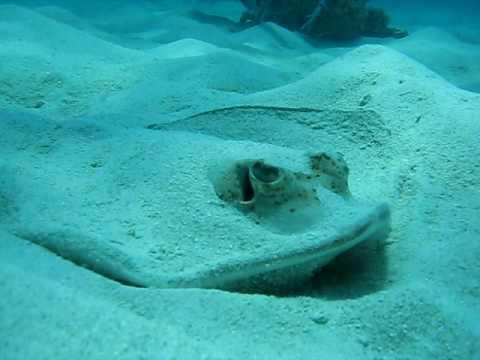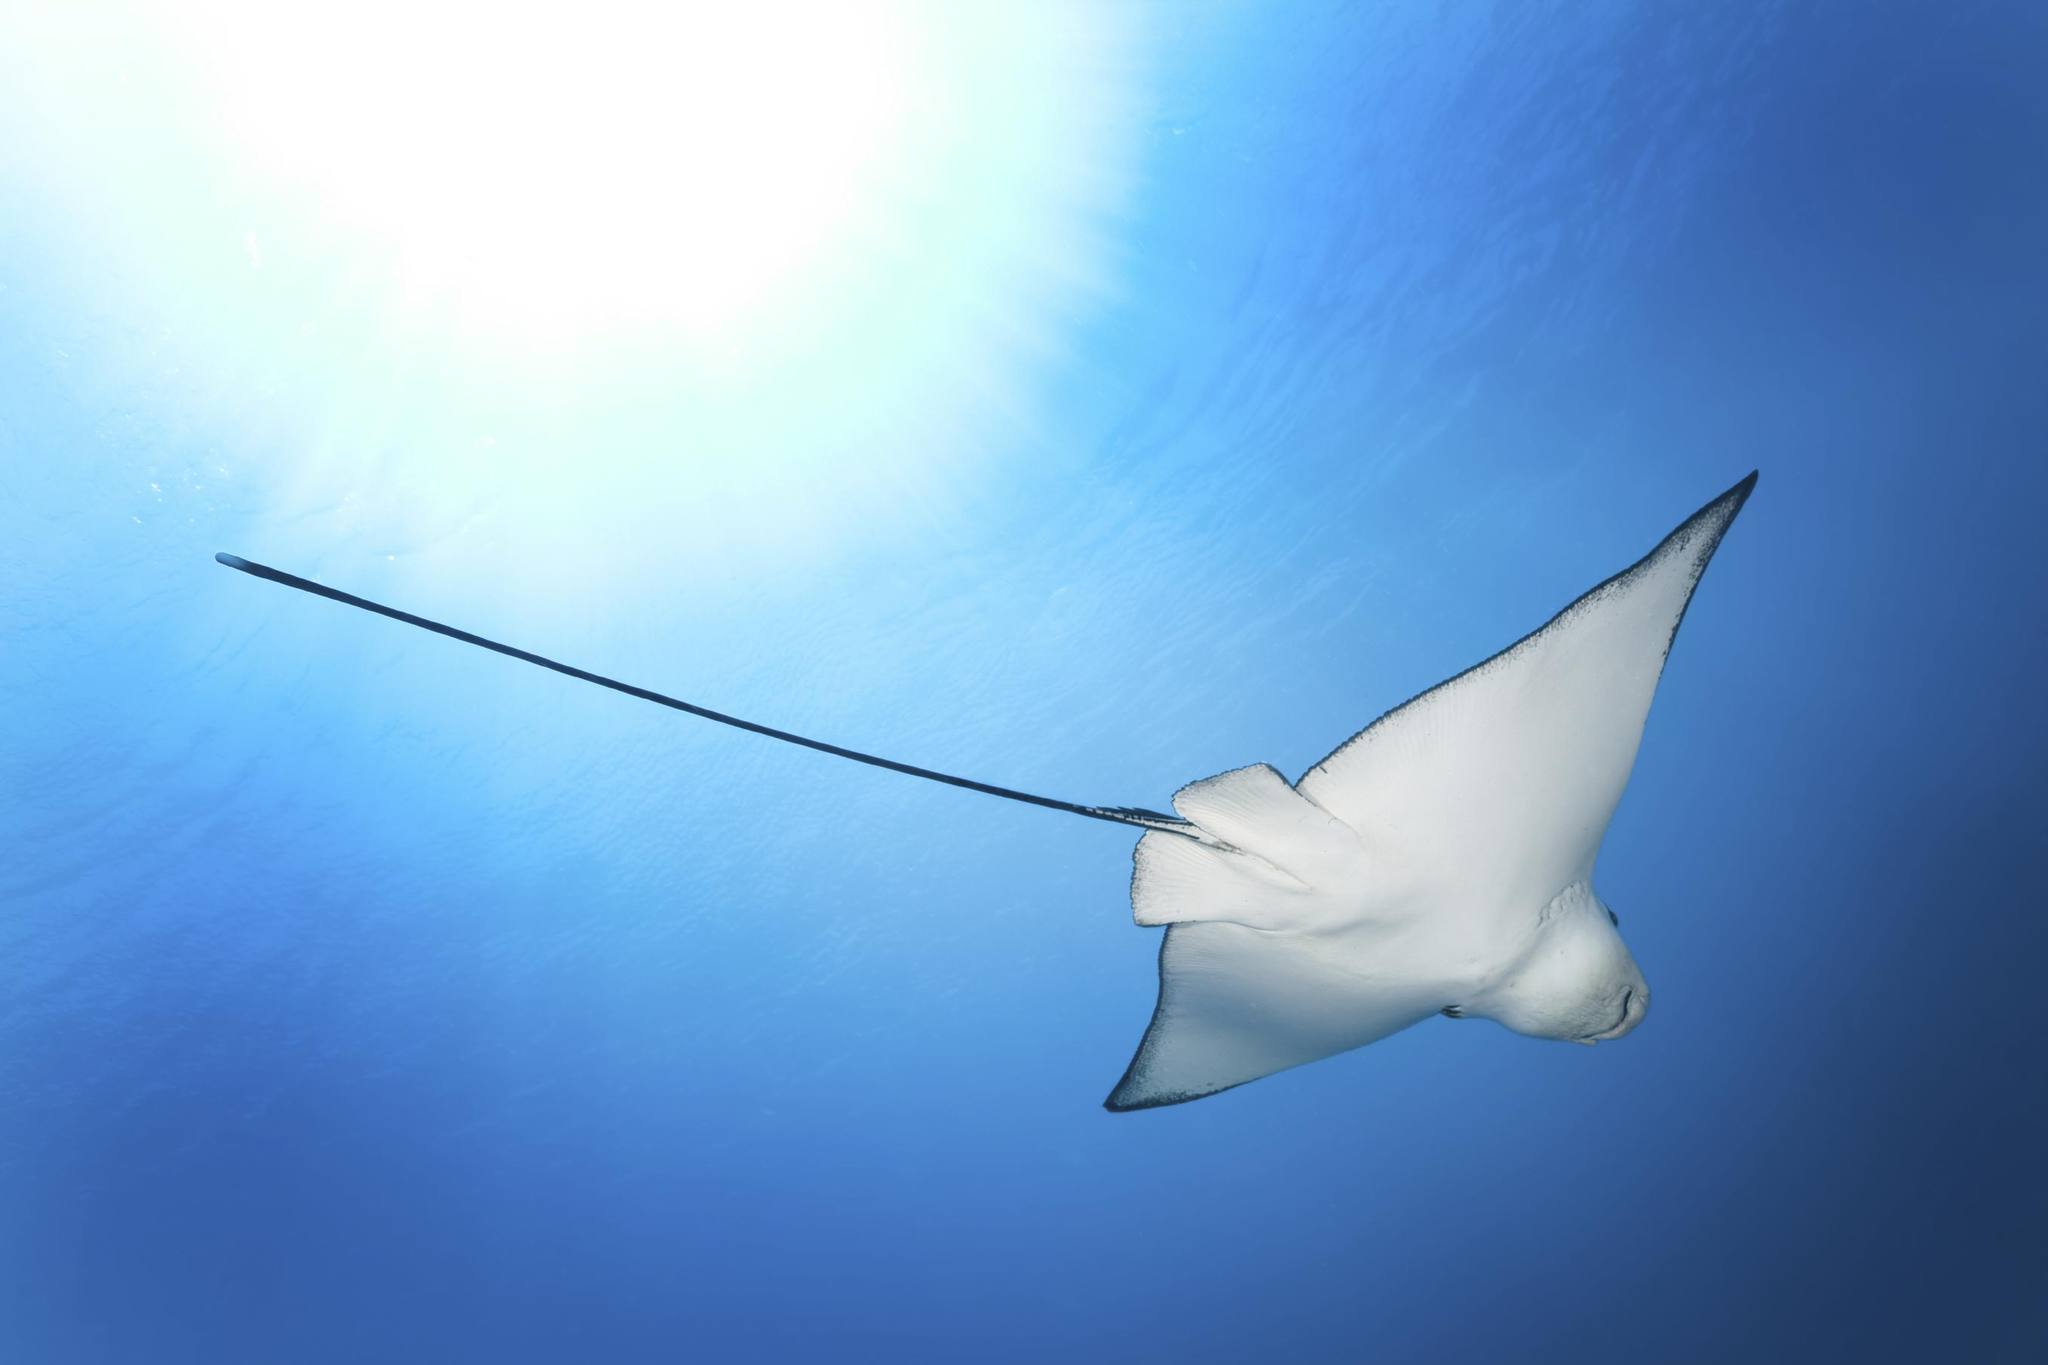The first image is the image on the left, the second image is the image on the right. For the images displayed, is the sentence "The ray in the image on the left is partially under the sand." factually correct? Answer yes or no. Yes. The first image is the image on the left, the second image is the image on the right. For the images shown, is this caption "An image shows one stingray, which is partly submerged in sand." true? Answer yes or no. Yes. 